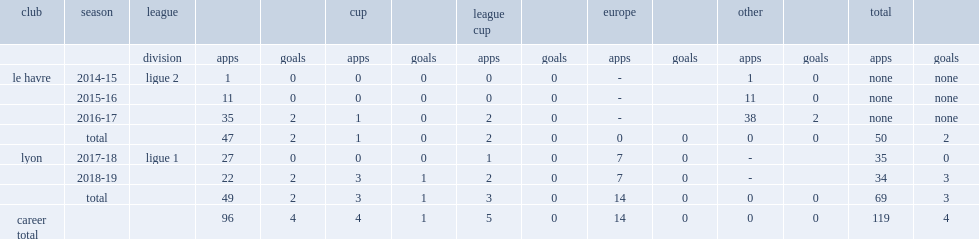Can you parse all the data within this table? {'header': ['club', 'season', 'league', '', '', 'cup', '', 'league cup', '', 'europe', '', 'other', '', 'total', ''], 'rows': [['', '', 'division', 'apps', 'goals', 'apps', 'goals', 'apps', 'goals', 'apps', 'goals', 'apps', 'goals', 'apps', 'goals'], ['le havre', '2014-15', 'ligue 2', '1', '0', '0', '0', '0', '0', '-', '', '1', '0', 'none', 'none'], ['', '2015-16', '', '11', '0', '0', '0', '0', '0', '-', '', '11', '0', 'none', 'none'], ['', '2016-17', '', '35', '2', '1', '0', '2', '0', '-', '', '38', '2', 'none', 'none'], ['', 'total', '', '47', '2', '1', '0', '2', '0', '0', '0', '0', '0', '50', '2'], ['lyon', '2017-18', 'ligue 1', '27', '0', '0', '0', '1', '0', '7', '0', '-', '', '35', '0'], ['', '2018-19', '', '22', '2', '3', '1', '2', '0', '7', '0', '-', '', '34', '3'], ['', 'total', '', '49', '2', '3', '1', '3', '0', '14', '0', '0', '0', '69', '3'], ['career total', '', '', '96', '4', '4', '1', '5', '0', '14', '0', '0', '0', '119', '4']]} In 2016-17 ligue 2 season, how many appearances did ferland mendy make for le havre? 35.0. 